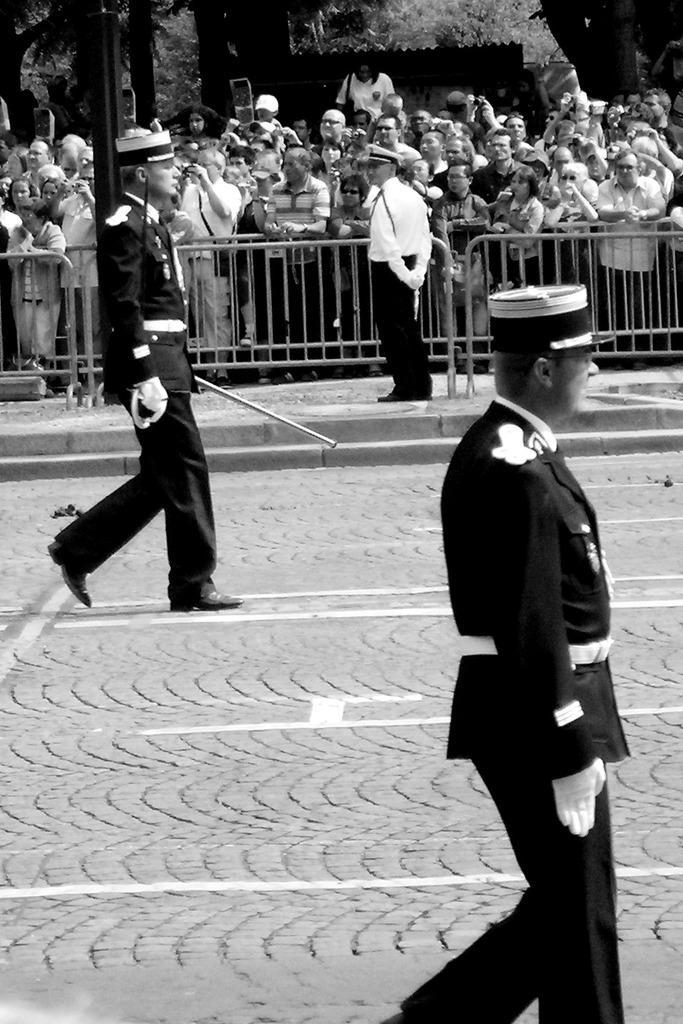Describe this image in one or two sentences. On the left side, there is a person in a uniform holding a stick with one hand and walking on the road on which, there are white color marks. On the right side, there is a person in an uniform wearing a white color glove walking. In the background, there is a person in white color shirt keeping both hands back and standing on the footpath near fencing. Outside the fencing, there are persons and there are trees. 